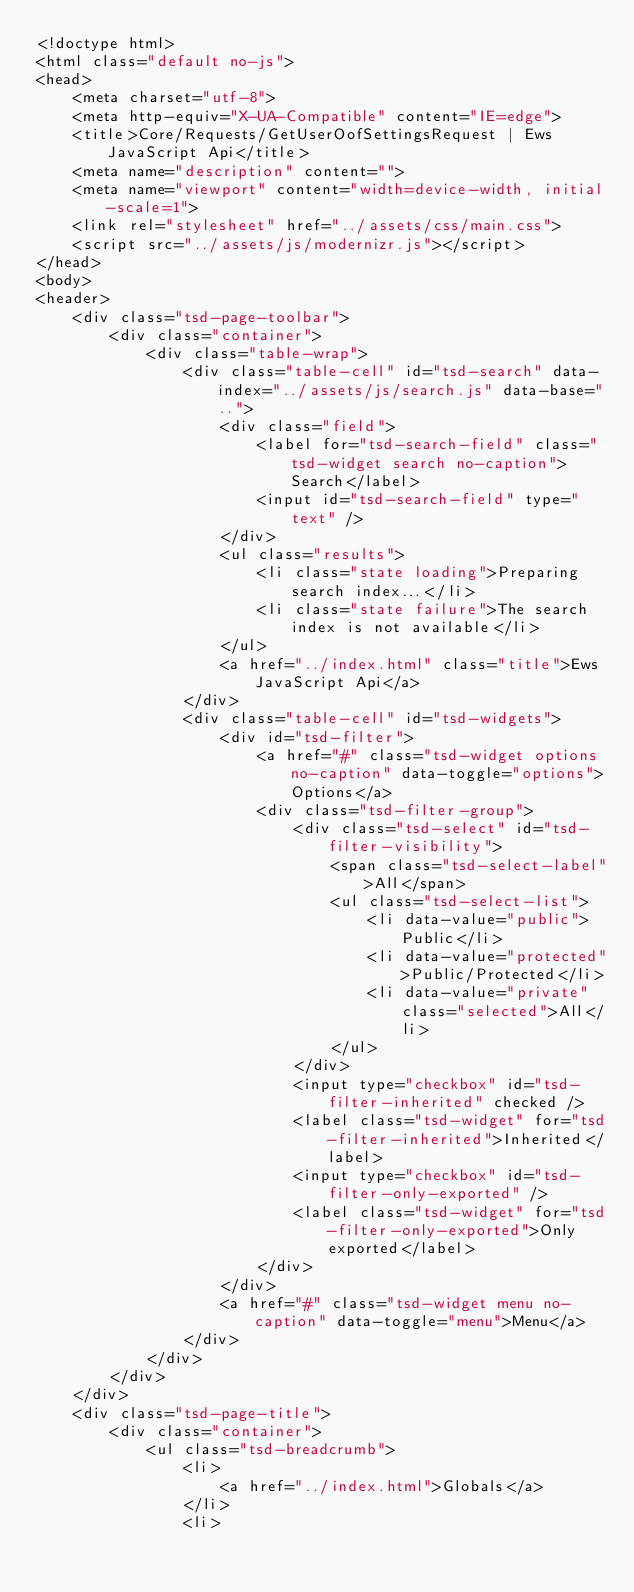<code> <loc_0><loc_0><loc_500><loc_500><_HTML_><!doctype html>
<html class="default no-js">
<head>
	<meta charset="utf-8">
	<meta http-equiv="X-UA-Compatible" content="IE=edge">
	<title>Core/Requests/GetUserOofSettingsRequest | Ews JavaScript Api</title>
	<meta name="description" content="">
	<meta name="viewport" content="width=device-width, initial-scale=1">
	<link rel="stylesheet" href="../assets/css/main.css">
	<script src="../assets/js/modernizr.js"></script>
</head>
<body>
<header>
	<div class="tsd-page-toolbar">
		<div class="container">
			<div class="table-wrap">
				<div class="table-cell" id="tsd-search" data-index="../assets/js/search.js" data-base="..">
					<div class="field">
						<label for="tsd-search-field" class="tsd-widget search no-caption">Search</label>
						<input id="tsd-search-field" type="text" />
					</div>
					<ul class="results">
						<li class="state loading">Preparing search index...</li>
						<li class="state failure">The search index is not available</li>
					</ul>
					<a href="../index.html" class="title">Ews JavaScript Api</a>
				</div>
				<div class="table-cell" id="tsd-widgets">
					<div id="tsd-filter">
						<a href="#" class="tsd-widget options no-caption" data-toggle="options">Options</a>
						<div class="tsd-filter-group">
							<div class="tsd-select" id="tsd-filter-visibility">
								<span class="tsd-select-label">All</span>
								<ul class="tsd-select-list">
									<li data-value="public">Public</li>
									<li data-value="protected">Public/Protected</li>
									<li data-value="private" class="selected">All</li>
								</ul>
							</div>
							<input type="checkbox" id="tsd-filter-inherited" checked />
							<label class="tsd-widget" for="tsd-filter-inherited">Inherited</label>
							<input type="checkbox" id="tsd-filter-only-exported" />
							<label class="tsd-widget" for="tsd-filter-only-exported">Only exported</label>
						</div>
					</div>
					<a href="#" class="tsd-widget menu no-caption" data-toggle="menu">Menu</a>
				</div>
			</div>
		</div>
	</div>
	<div class="tsd-page-title">
		<div class="container">
			<ul class="tsd-breadcrumb">
				<li>
					<a href="../index.html">Globals</a>
				</li>
				<li></code> 